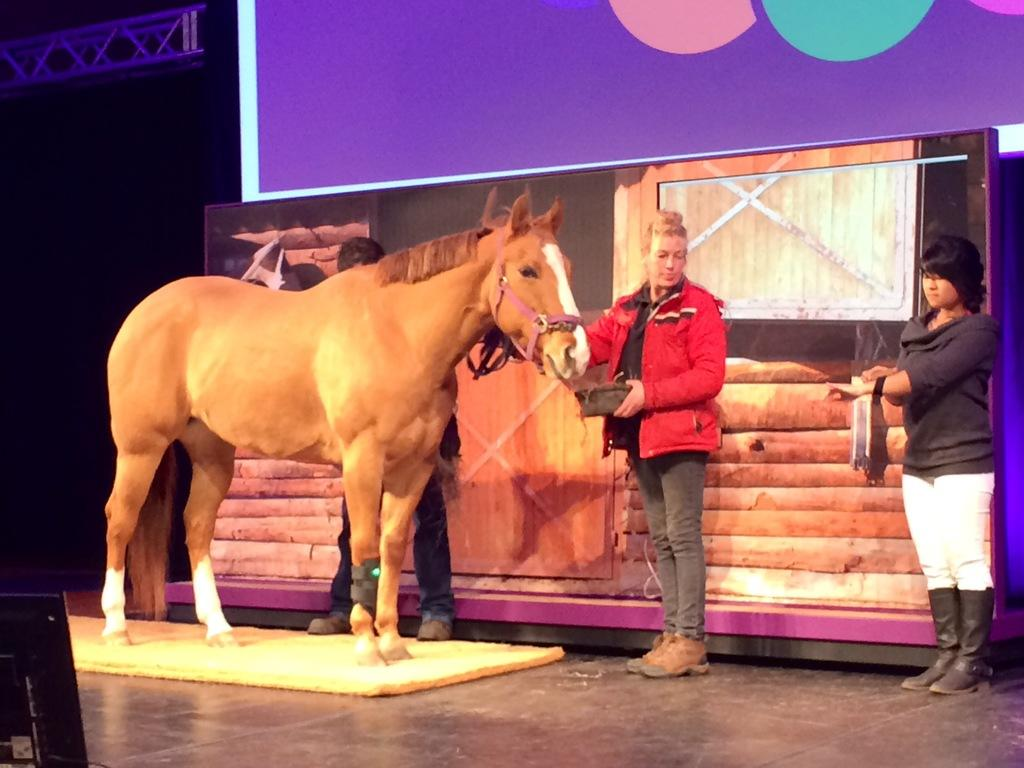How many people are present in the image? There are three people standing in the image. What other living creature is present in the image? There is a horse in the image. What object can be used for holding or serving food? There is a bowl in the image. What type of sign is visible in the image? There is a banner in the image. What can be inferred about the lighting conditions in the image? The background of the image is dark. What type of arithmetic problem is being solved by the horse in the image? There is no arithmetic problem being solved by the horse in the image, as it is a living creature and not capable of performing arithmetic. In which direction is the horse facing in the image? The direction the horse is facing cannot be determined from the image alone, as it only provides a static view of the scene. 